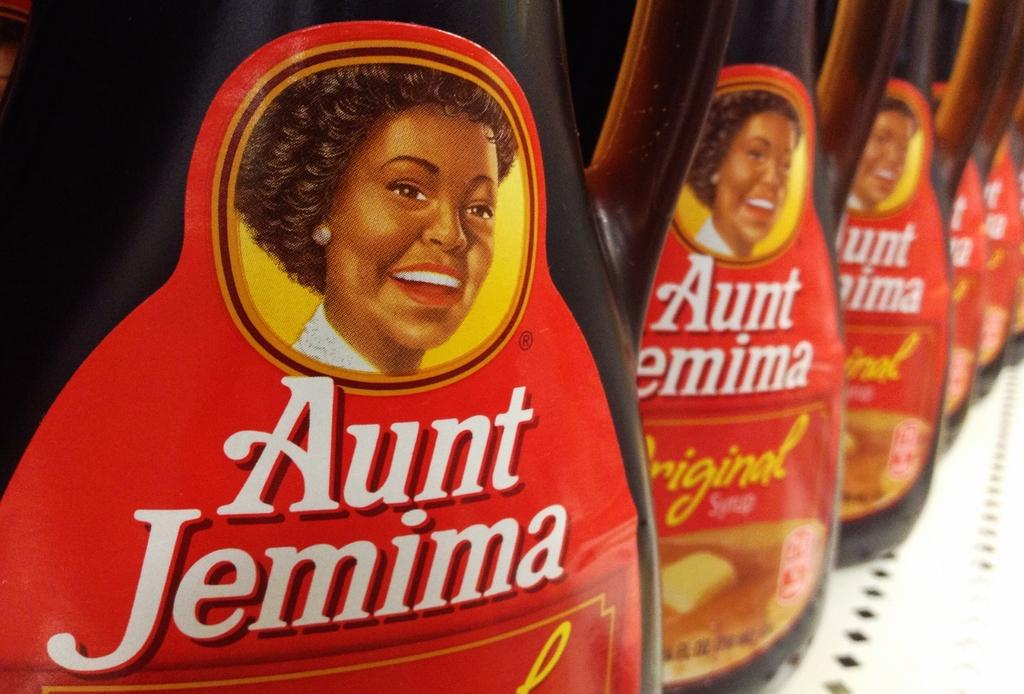What objects are present in the image related to syrup? There are two syrup bottles in the image. What is depicted on the syrup bottles? There is a picture of a woman on the syrup bottles. How many girls are present in the image? There are no girls present in the image; it only features syrup bottles with a picture of a woman. What type of company is represented by the syrup bottles? The image does not provide information about the company that produces the syrup bottles. 